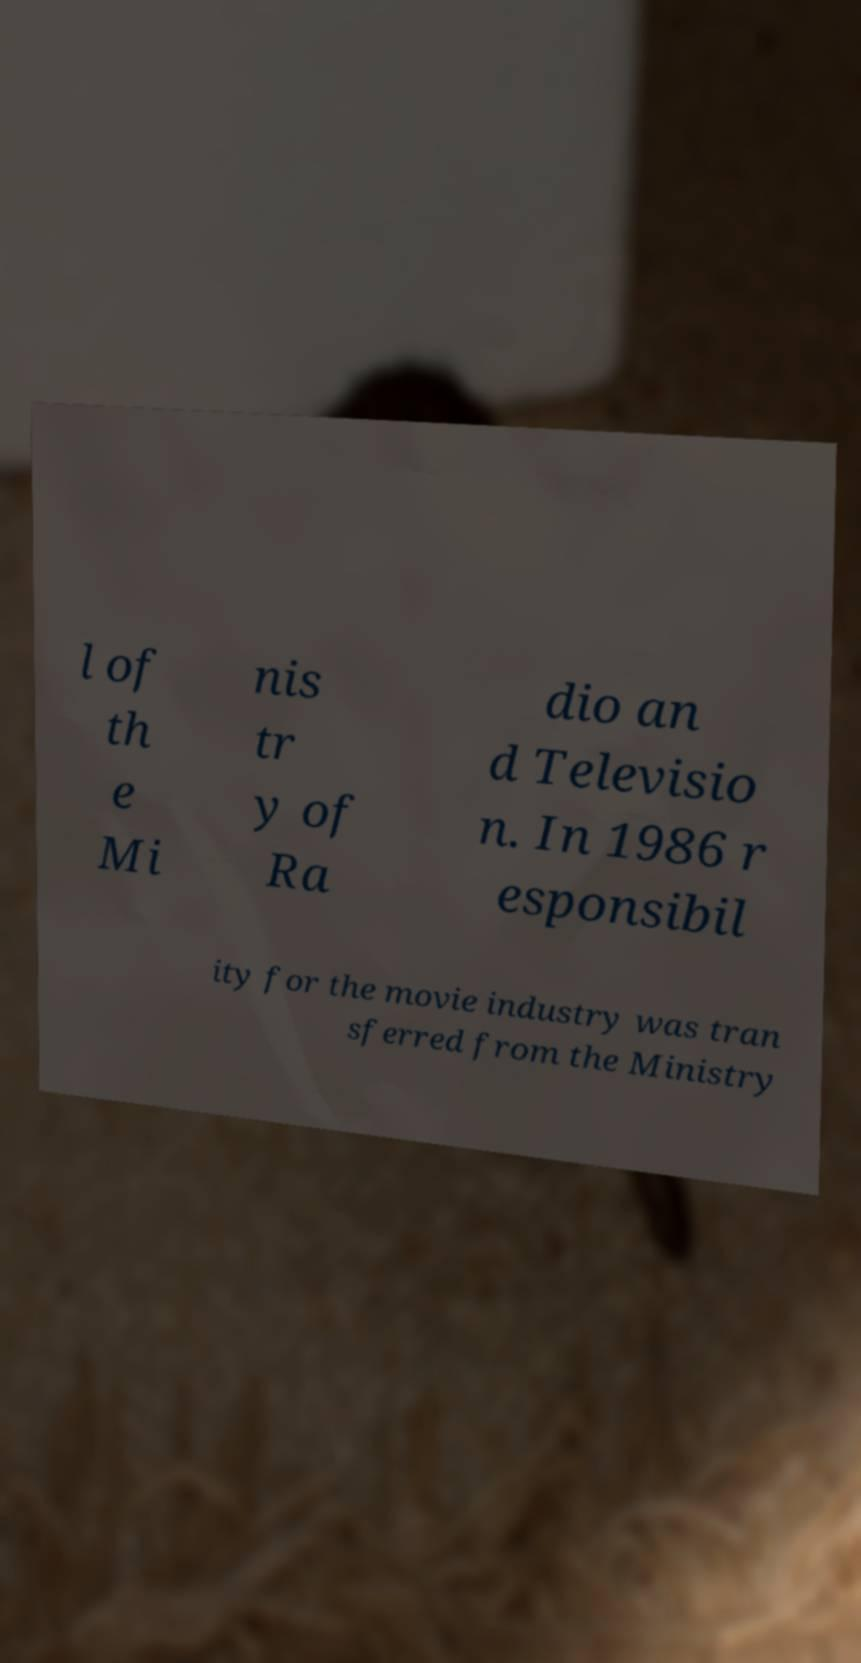What messages or text are displayed in this image? I need them in a readable, typed format. l of th e Mi nis tr y of Ra dio an d Televisio n. In 1986 r esponsibil ity for the movie industry was tran sferred from the Ministry 